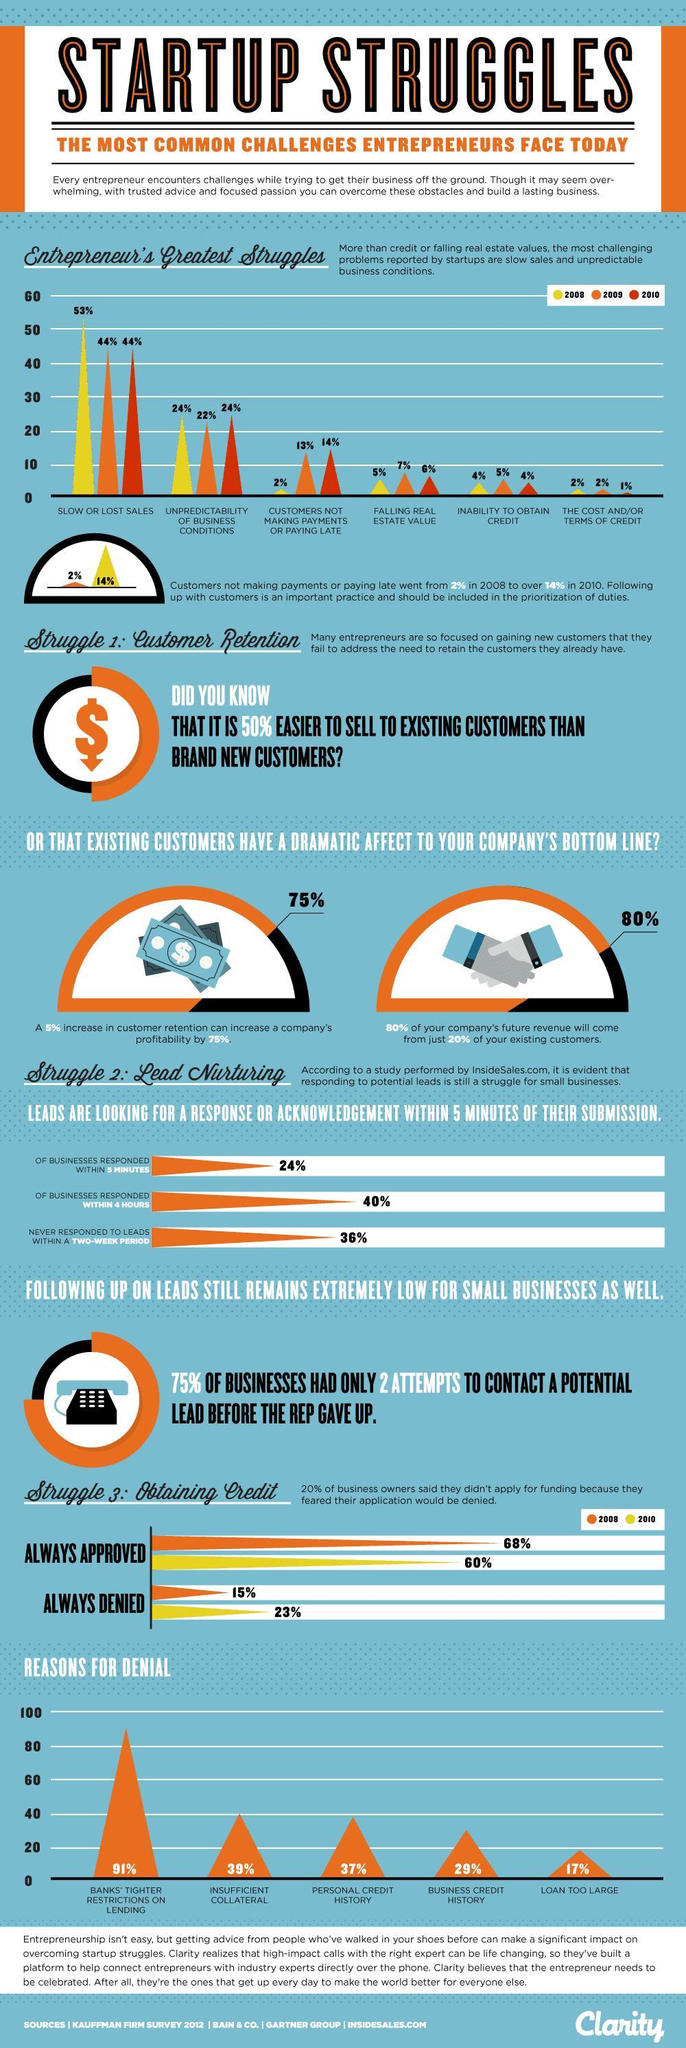Give the percentage of businesses suffering due to uncertain business environment in 2010?
Answer the question with a short phrase. 24% What percentage of entreprenuer's failed to get credit 2009? 5% What is the percentage of businesses that do not reply to leads in 5 minutes? 76% Calculate the percentage increase in late payments from the year 2008 to 2010? 12% What percentage of businesses could not obtain approval for credit in 2010? 40% What the percentage of entrepreneur's did not receive payments in 2008? 2% What is percentage difference in credits being denied due insufficient collateral and personal credit history? 1% 